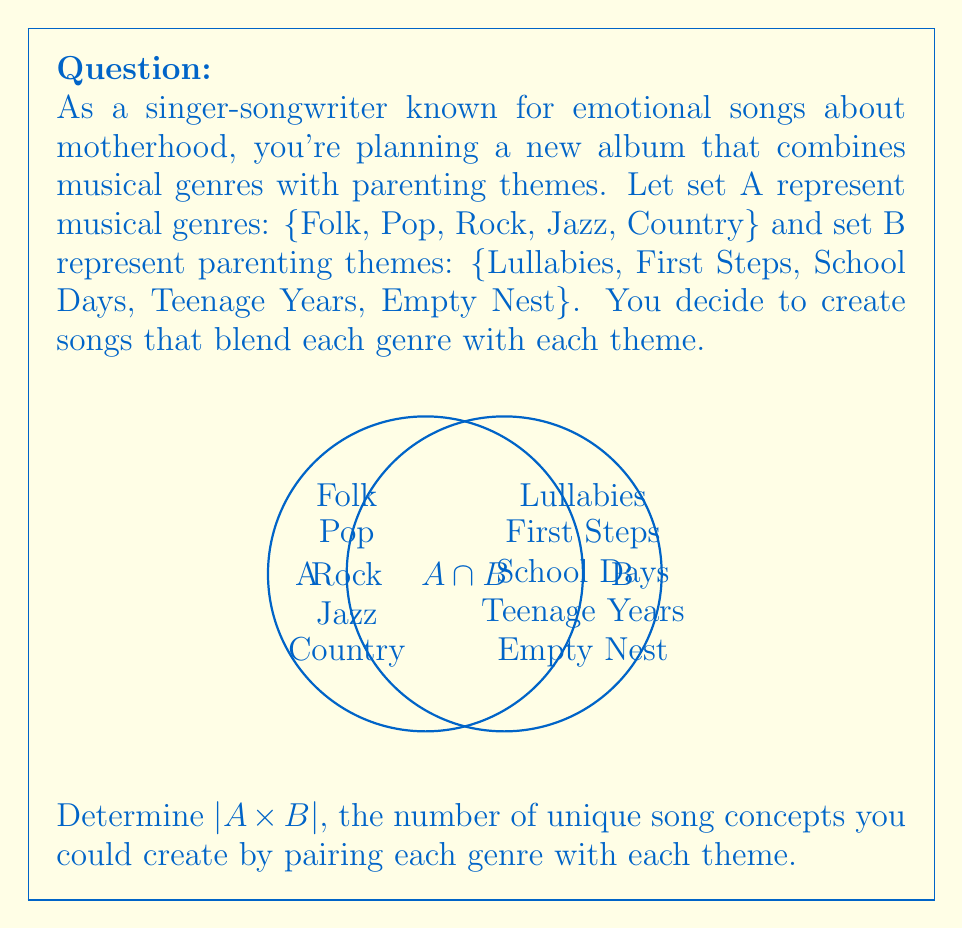Give your solution to this math problem. To solve this problem, we need to understand the concept of Cartesian product and its cardinality:

1) The Cartesian product of two sets A and B, denoted as $A \times B$, is the set of all ordered pairs (a, b) where a ∈ A and b ∈ B.

2) The cardinality of the Cartesian product of two finite sets is given by the formula:
   $|A \times B| = |A| \cdot |B|$

3) In this case:
   $|A| = 5$ (number of musical genres)
   $|B| = 5$ (number of parenting themes)

4) Therefore:
   $|A \times B| = |A| \cdot |B| = 5 \cdot 5 = 25$

This means you could create 25 unique song concepts by pairing each musical genre with each parenting theme.
Answer: 25 